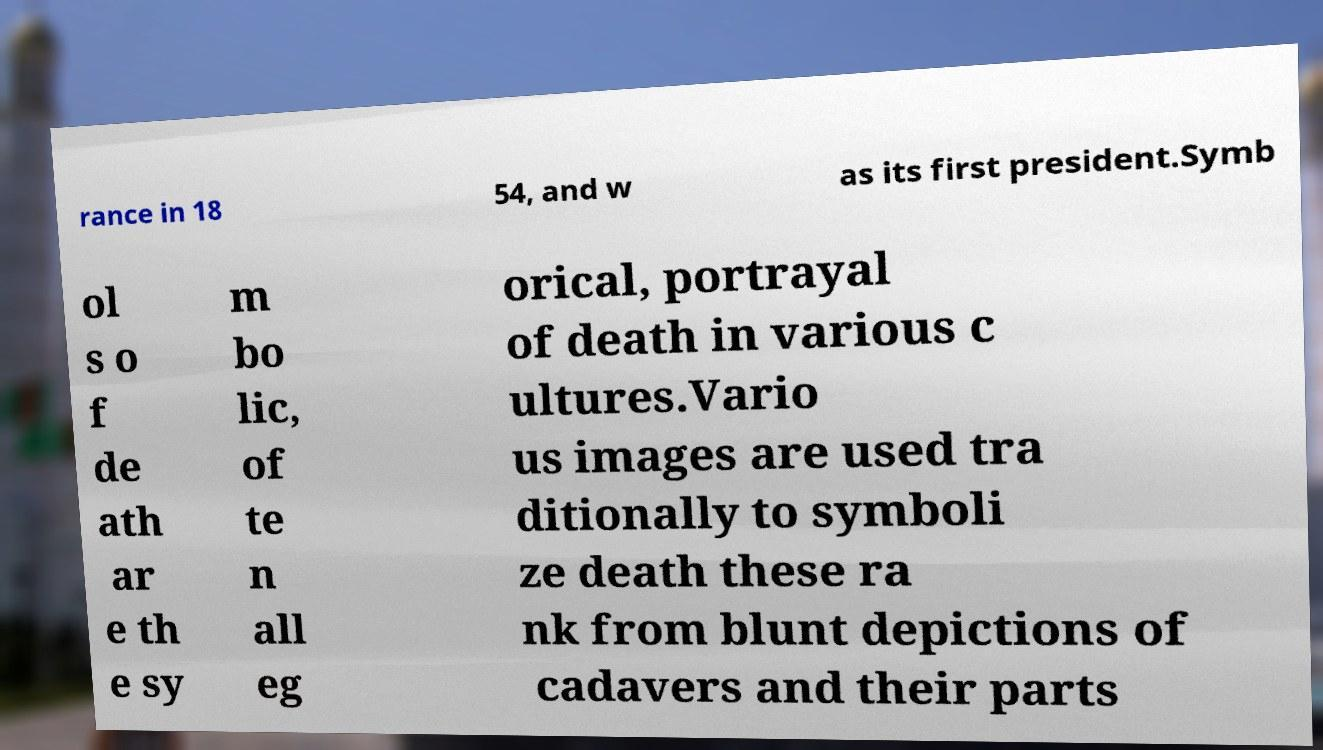For documentation purposes, I need the text within this image transcribed. Could you provide that? rance in 18 54, and w as its first president.Symb ol s o f de ath ar e th e sy m bo lic, of te n all eg orical, portrayal of death in various c ultures.Vario us images are used tra ditionally to symboli ze death these ra nk from blunt depictions of cadavers and their parts 